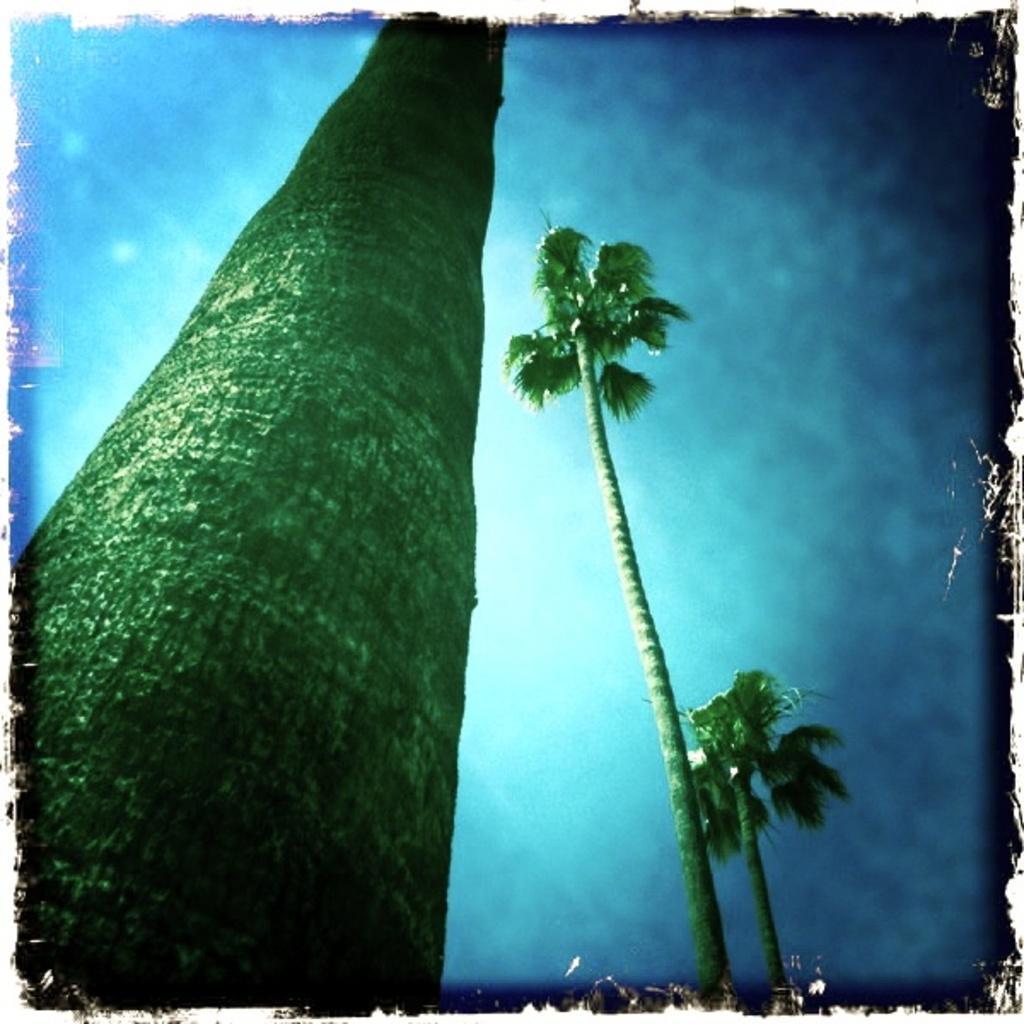Could you give a brief overview of what you see in this image? In the image I can see trees. In the background I can see the sky. 